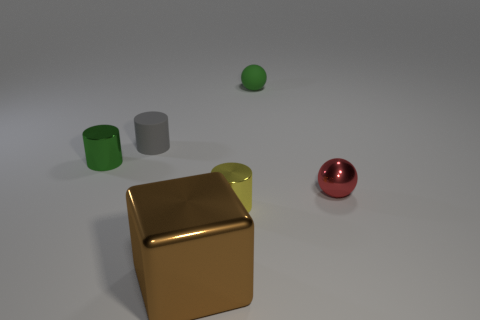Subtract all gray rubber cylinders. How many cylinders are left? 2 Add 1 big cubes. How many objects exist? 7 Subtract 1 balls. How many balls are left? 1 Subtract all green cylinders. How many cylinders are left? 2 Subtract all balls. How many objects are left? 4 Add 4 small spheres. How many small spheres are left? 6 Add 4 small brown matte cylinders. How many small brown matte cylinders exist? 4 Subtract 0 green cubes. How many objects are left? 6 Subtract all yellow blocks. Subtract all blue spheres. How many blocks are left? 1 Subtract all green blocks. How many gray cylinders are left? 1 